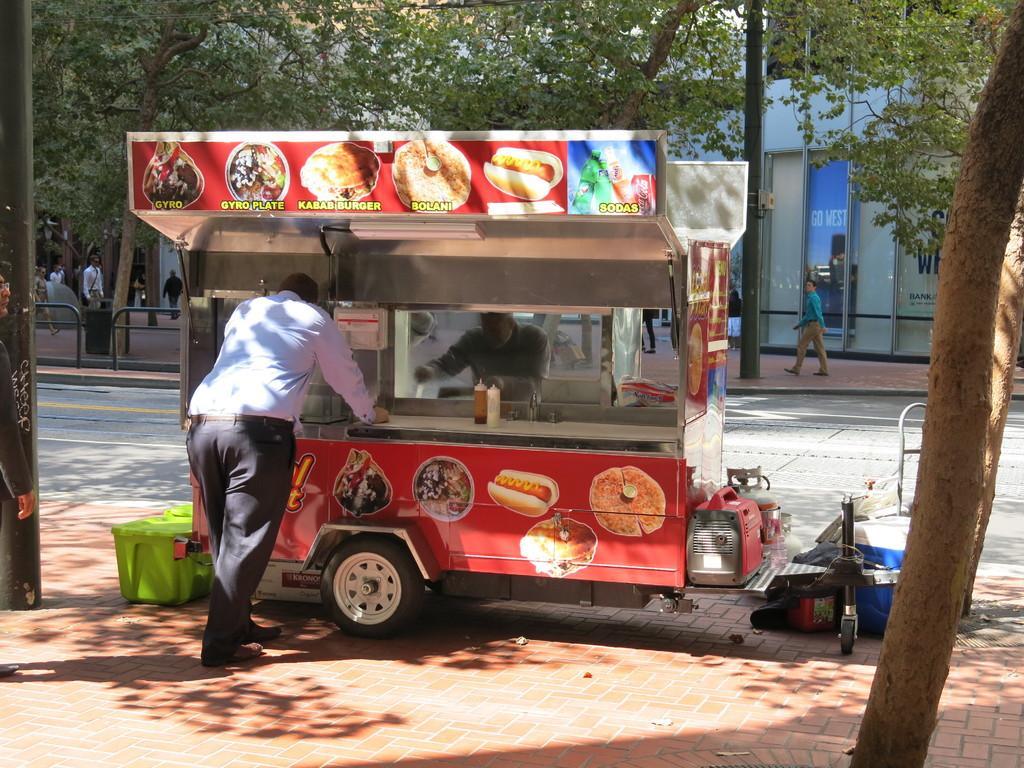Describe this image in one or two sentences. This is the picture of a place where we have a vehicle on which there is board which has some food items on it and around there are some trees, people and a fencing. 